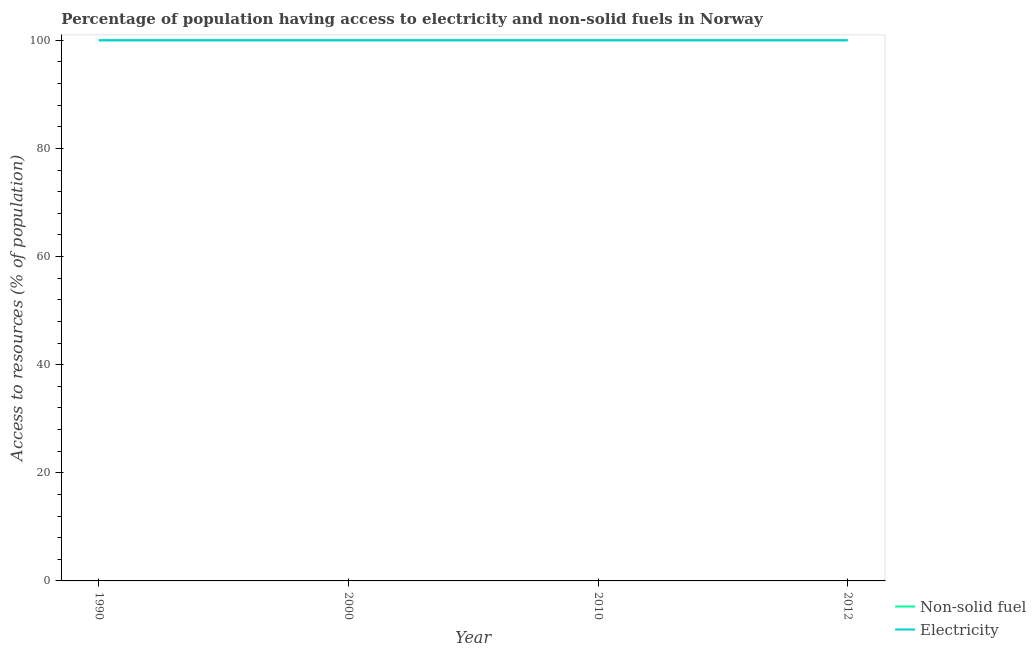What is the percentage of population having access to electricity in 2000?
Offer a very short reply. 100. Across all years, what is the maximum percentage of population having access to electricity?
Give a very brief answer. 100. Across all years, what is the minimum percentage of population having access to non-solid fuel?
Keep it short and to the point. 100. In which year was the percentage of population having access to electricity maximum?
Provide a short and direct response. 1990. In which year was the percentage of population having access to non-solid fuel minimum?
Your answer should be very brief. 1990. What is the total percentage of population having access to electricity in the graph?
Keep it short and to the point. 400. What is the average percentage of population having access to electricity per year?
Provide a succinct answer. 100. What is the ratio of the percentage of population having access to non-solid fuel in 2010 to that in 2012?
Offer a terse response. 1. Is the percentage of population having access to electricity in 2000 less than that in 2010?
Offer a very short reply. No. What is the difference between the highest and the second highest percentage of population having access to non-solid fuel?
Your response must be concise. 0. Does the percentage of population having access to electricity monotonically increase over the years?
Offer a terse response. No. What is the difference between two consecutive major ticks on the Y-axis?
Provide a short and direct response. 20. Does the graph contain grids?
Your answer should be compact. No. How many legend labels are there?
Make the answer very short. 2. What is the title of the graph?
Offer a very short reply. Percentage of population having access to electricity and non-solid fuels in Norway. Does "Borrowers" appear as one of the legend labels in the graph?
Keep it short and to the point. No. What is the label or title of the Y-axis?
Provide a succinct answer. Access to resources (% of population). What is the Access to resources (% of population) in Non-solid fuel in 1990?
Keep it short and to the point. 100. What is the Access to resources (% of population) in Non-solid fuel in 2000?
Offer a very short reply. 100. What is the Access to resources (% of population) in Non-solid fuel in 2010?
Offer a very short reply. 100. What is the Access to resources (% of population) in Electricity in 2010?
Offer a terse response. 100. Across all years, what is the maximum Access to resources (% of population) of Non-solid fuel?
Your response must be concise. 100. Across all years, what is the maximum Access to resources (% of population) in Electricity?
Your answer should be very brief. 100. Across all years, what is the minimum Access to resources (% of population) in Electricity?
Provide a succinct answer. 100. What is the total Access to resources (% of population) of Electricity in the graph?
Offer a very short reply. 400. What is the difference between the Access to resources (% of population) in Non-solid fuel in 1990 and that in 2000?
Keep it short and to the point. 0. What is the difference between the Access to resources (% of population) of Electricity in 1990 and that in 2000?
Your response must be concise. 0. What is the difference between the Access to resources (% of population) of Non-solid fuel in 1990 and that in 2012?
Keep it short and to the point. 0. What is the difference between the Access to resources (% of population) in Electricity in 2000 and that in 2010?
Provide a succinct answer. 0. What is the difference between the Access to resources (% of population) in Non-solid fuel in 2010 and that in 2012?
Ensure brevity in your answer.  0. What is the difference between the Access to resources (% of population) in Electricity in 2010 and that in 2012?
Provide a short and direct response. 0. What is the difference between the Access to resources (% of population) of Non-solid fuel in 1990 and the Access to resources (% of population) of Electricity in 2000?
Your response must be concise. 0. What is the difference between the Access to resources (% of population) in Non-solid fuel in 1990 and the Access to resources (% of population) in Electricity in 2010?
Provide a succinct answer. 0. What is the difference between the Access to resources (% of population) of Non-solid fuel in 1990 and the Access to resources (% of population) of Electricity in 2012?
Provide a short and direct response. 0. What is the difference between the Access to resources (% of population) of Non-solid fuel in 2000 and the Access to resources (% of population) of Electricity in 2010?
Ensure brevity in your answer.  0. What is the difference between the Access to resources (% of population) in Non-solid fuel in 2000 and the Access to resources (% of population) in Electricity in 2012?
Offer a terse response. 0. What is the difference between the Access to resources (% of population) in Non-solid fuel in 2010 and the Access to resources (% of population) in Electricity in 2012?
Give a very brief answer. 0. In the year 1990, what is the difference between the Access to resources (% of population) of Non-solid fuel and Access to resources (% of population) of Electricity?
Your response must be concise. 0. What is the ratio of the Access to resources (% of population) in Electricity in 1990 to that in 2000?
Your answer should be compact. 1. What is the ratio of the Access to resources (% of population) in Non-solid fuel in 1990 to that in 2010?
Your answer should be very brief. 1. What is the ratio of the Access to resources (% of population) of Electricity in 2000 to that in 2010?
Provide a short and direct response. 1. What is the ratio of the Access to resources (% of population) of Electricity in 2000 to that in 2012?
Your response must be concise. 1. What is the ratio of the Access to resources (% of population) of Non-solid fuel in 2010 to that in 2012?
Make the answer very short. 1. What is the difference between the highest and the second highest Access to resources (% of population) of Non-solid fuel?
Give a very brief answer. 0. What is the difference between the highest and the second highest Access to resources (% of population) in Electricity?
Give a very brief answer. 0. What is the difference between the highest and the lowest Access to resources (% of population) of Non-solid fuel?
Make the answer very short. 0. 